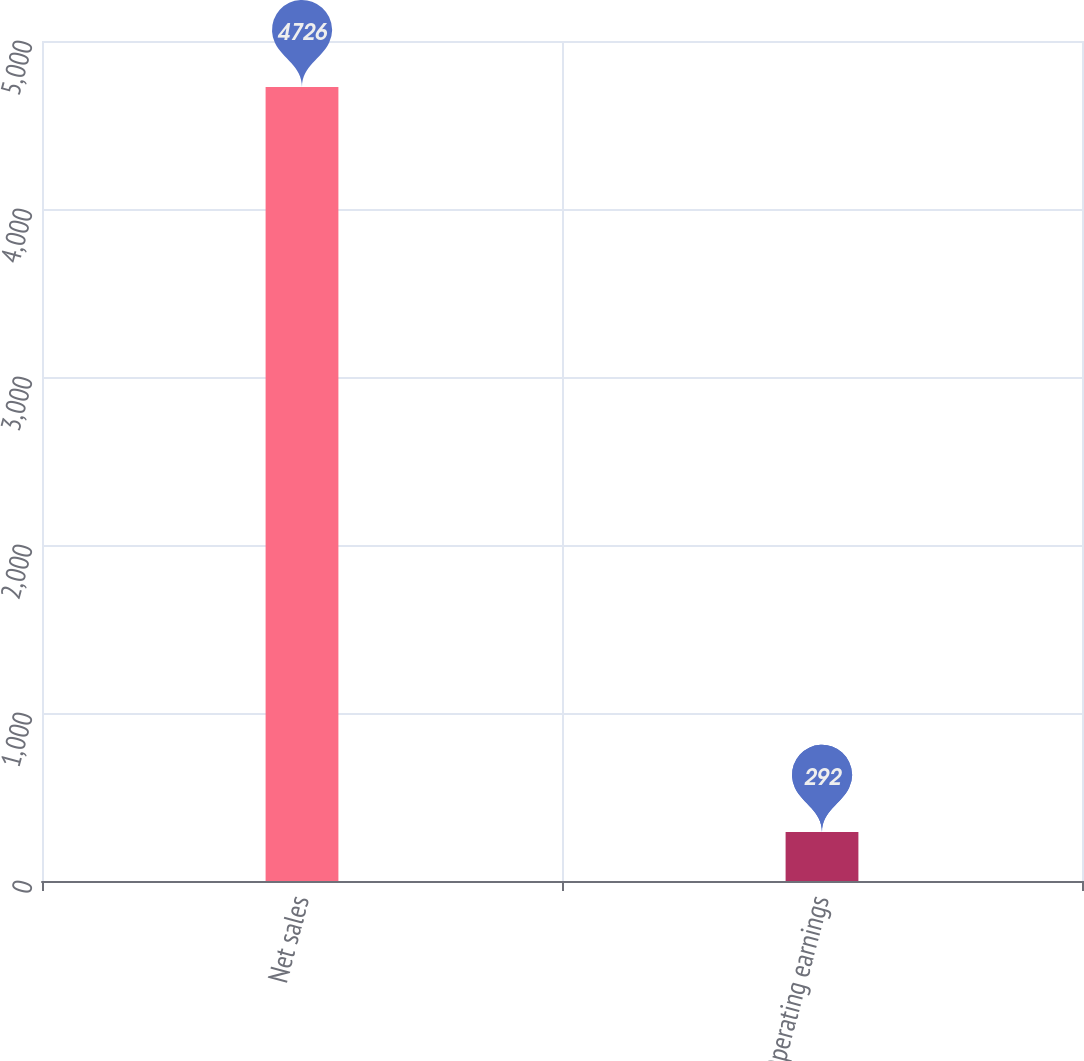<chart> <loc_0><loc_0><loc_500><loc_500><bar_chart><fcel>Net sales<fcel>Operating earnings<nl><fcel>4726<fcel>292<nl></chart> 